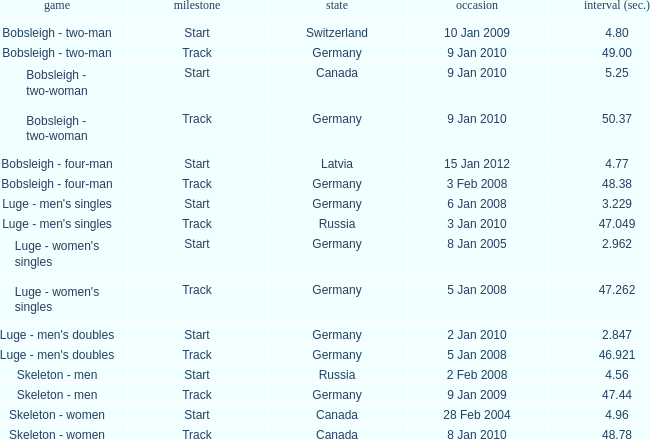Which sport has a time over 49? Bobsleigh - two-woman. 